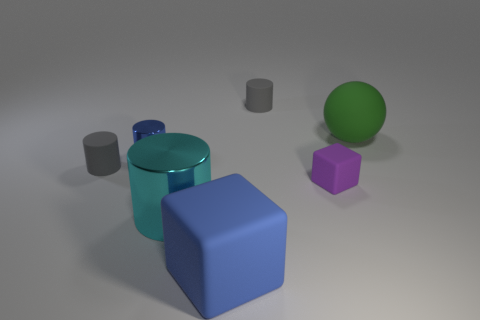What number of things are large metallic objects or big green balls?
Your answer should be very brief. 2. There is a green matte sphere; are there any big rubber cubes behind it?
Offer a terse response. No. Is there a small gray block that has the same material as the green object?
Provide a short and direct response. No. There is a object that is the same color as the small metallic cylinder; what is its size?
Offer a very short reply. Large. What number of blocks are either large blue rubber things or large green rubber objects?
Your answer should be compact. 1. Are there more green spheres that are behind the big green matte object than small rubber cubes behind the purple matte object?
Make the answer very short. No. How many tiny metal objects are the same color as the matte sphere?
Make the answer very short. 0. The green object that is made of the same material as the tiny purple cube is what size?
Your answer should be compact. Large. What number of things are blue things to the left of the big metallic thing or small red metal cylinders?
Provide a succinct answer. 1. There is a rubber cylinder on the right side of the big block; is its color the same as the rubber sphere?
Your answer should be compact. No. 